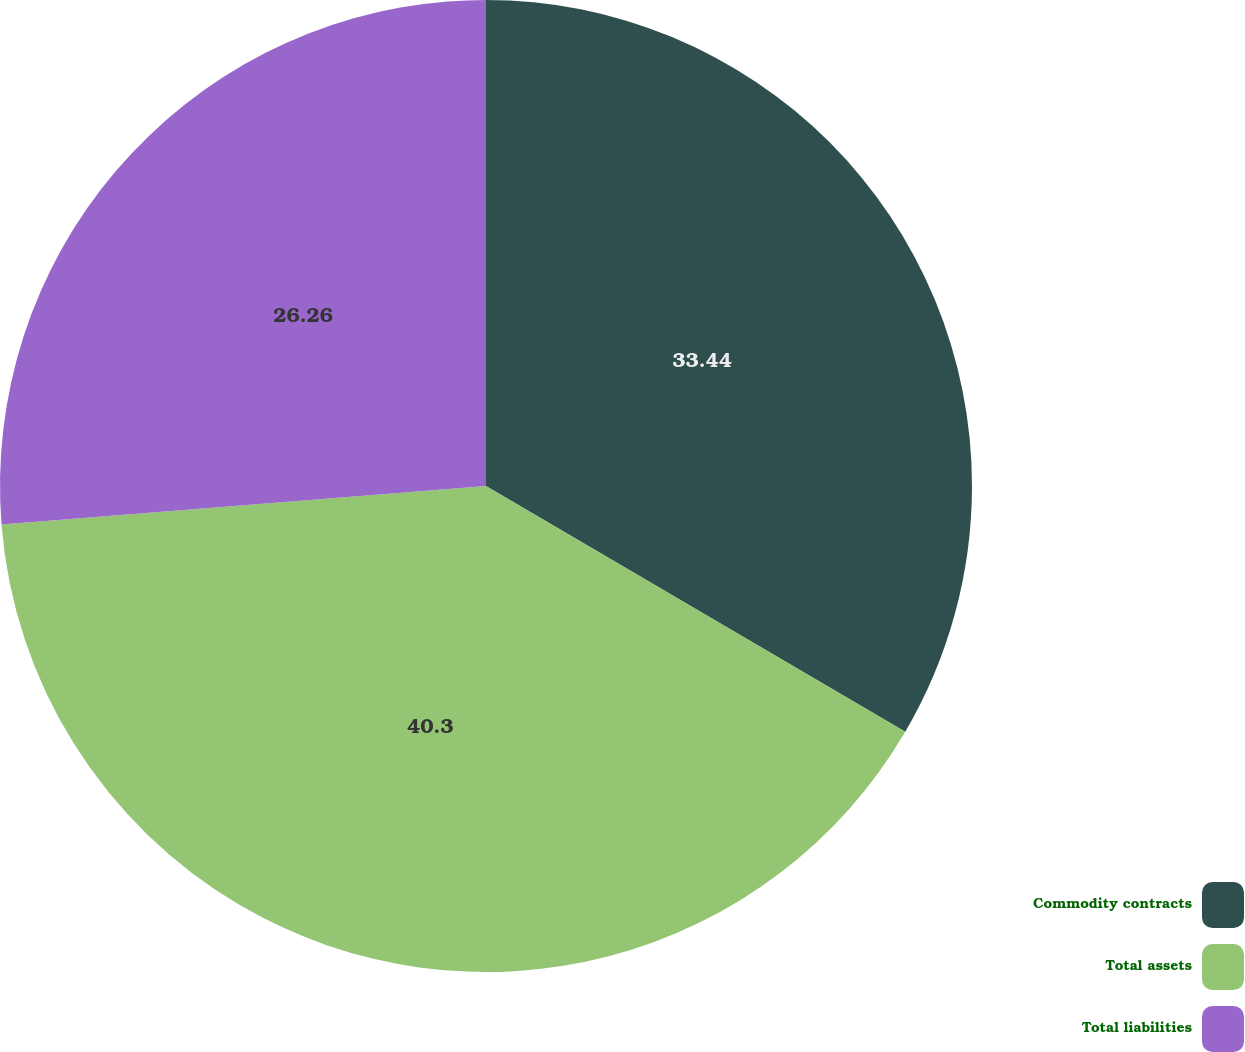<chart> <loc_0><loc_0><loc_500><loc_500><pie_chart><fcel>Commodity contracts<fcel>Total assets<fcel>Total liabilities<nl><fcel>33.44%<fcel>40.3%<fcel>26.26%<nl></chart> 